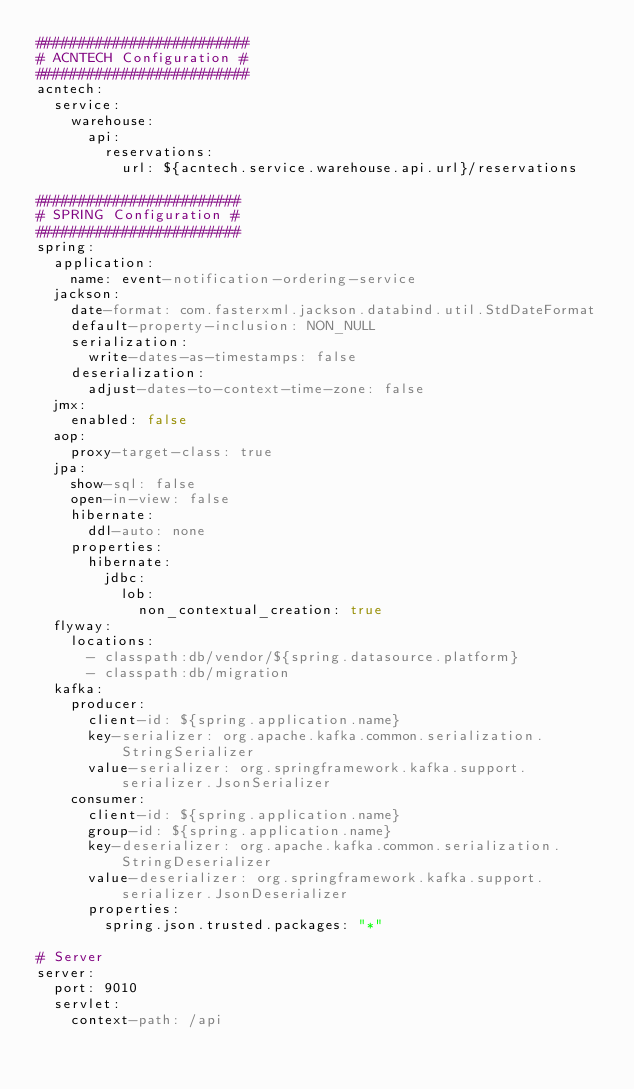Convert code to text. <code><loc_0><loc_0><loc_500><loc_500><_YAML_>#########################
# ACNTECH Configuration #
#########################
acntech:
  service:
    warehouse:
      api:
        reservations:
          url: ${acntech.service.warehouse.api.url}/reservations

########################
# SPRING Configuration #
########################
spring:
  application:
    name: event-notification-ordering-service
  jackson:
    date-format: com.fasterxml.jackson.databind.util.StdDateFormat
    default-property-inclusion: NON_NULL
    serialization:
      write-dates-as-timestamps: false
    deserialization:
      adjust-dates-to-context-time-zone: false
  jmx:
    enabled: false
  aop:
    proxy-target-class: true
  jpa:
    show-sql: false
    open-in-view: false
    hibernate:
      ddl-auto: none
    properties:
      hibernate:
        jdbc:
          lob:
            non_contextual_creation: true
  flyway:
    locations:
      - classpath:db/vendor/${spring.datasource.platform}
      - classpath:db/migration
  kafka:
    producer:
      client-id: ${spring.application.name}
      key-serializer: org.apache.kafka.common.serialization.StringSerializer
      value-serializer: org.springframework.kafka.support.serializer.JsonSerializer
    consumer:
      client-id: ${spring.application.name}
      group-id: ${spring.application.name}
      key-deserializer: org.apache.kafka.common.serialization.StringDeserializer
      value-deserializer: org.springframework.kafka.support.serializer.JsonDeserializer
      properties:
        spring.json.trusted.packages: "*"

# Server
server:
  port: 9010
  servlet:
    context-path: /api
</code> 